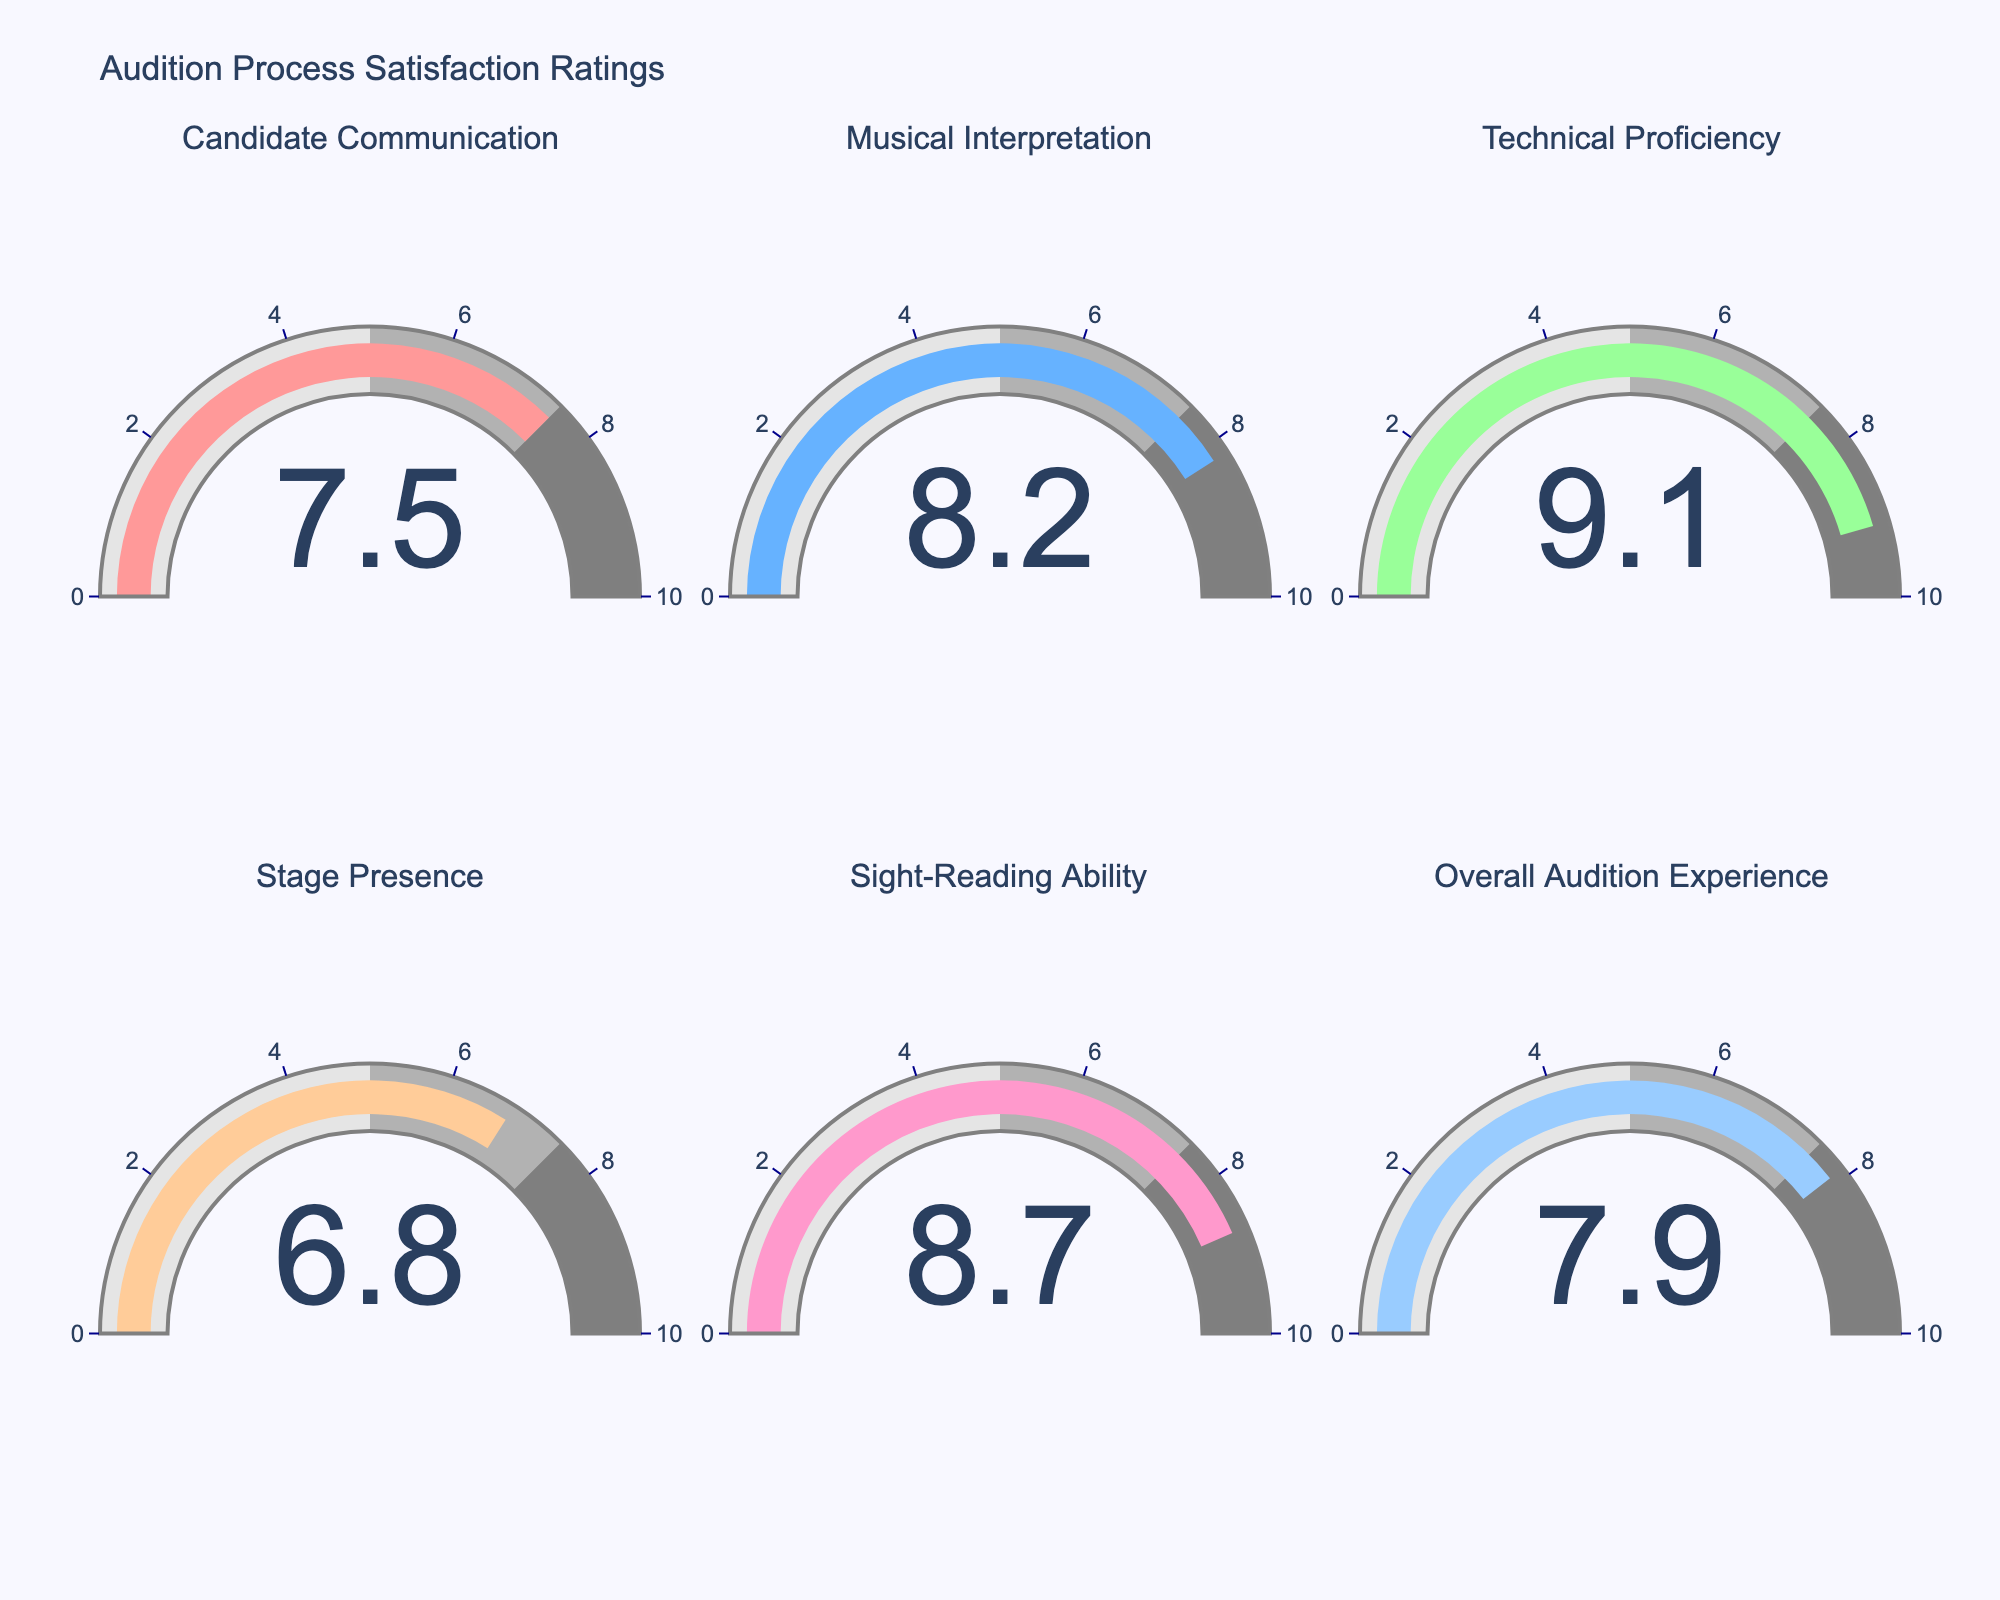What's the highest satisfaction rating? The highest satisfaction rating is indicated by the length and end point of each gauge. By examining the gauge charts, Technical Proficiency has the highest rating.
Answer: Technical Proficiency, 9.1 What's the lowest satisfaction rating? The lowest satisfaction rating is indicated by the length and position of the needle on each gauge. Stage Presence has the lowest rating.
Answer: Stage Presence, 6.8 What is the overall average satisfaction rating? To find the average, add all the ratings and divide by the number of categories: (7.5 + 8.2 + 9.1 + 6.8 + 8.7 + 7.9) / 6. The sum is 48.2, so the average is 48.2 / 6 = 8.03.
Answer: 8.03 Which metric falls within the range of 7.5 to 8.0? By visually referencing each gauge, Candidate Communication has a rating of 7.5 and Overall Audition Experience has a rating of 7.9, both within the range of 7.5 to 8.0.
Answer: Candidate Communication, Overall Audition Experience How many metrics have a rating equal to or above 8? Check each gauge chart: Musical Interpretation, Technical Proficiency, Sight-Reading Ability, and Overall Audition Experience are equal to or above 8.
Answer: Four metrics Which rating is closest to 7? Compare all values to 7 and determine that Stage Presence at 6.8 is closest to 7.
Answer: Stage Presence, 6.8 Is the Sight-Reading Ability rated higher than the Overall Audition Experience? Sight-Reading Ability rating is 8.7, higher than Overall Audition Experience at 7.9.
Answer: Yes Calculate the total sum of all the satisfaction ratings. Sum all the ratings: 7.5 + 8.2 + 9.1 + 6.8 + 8.7 + 7.9 = 48.2.
Answer: 48.2 Which metric has a rating just under 8? By visually inspecting each gauge, Candidate Communication is at 7.5, which is just under 8.
Answer: Candidate Communication, 7.5 